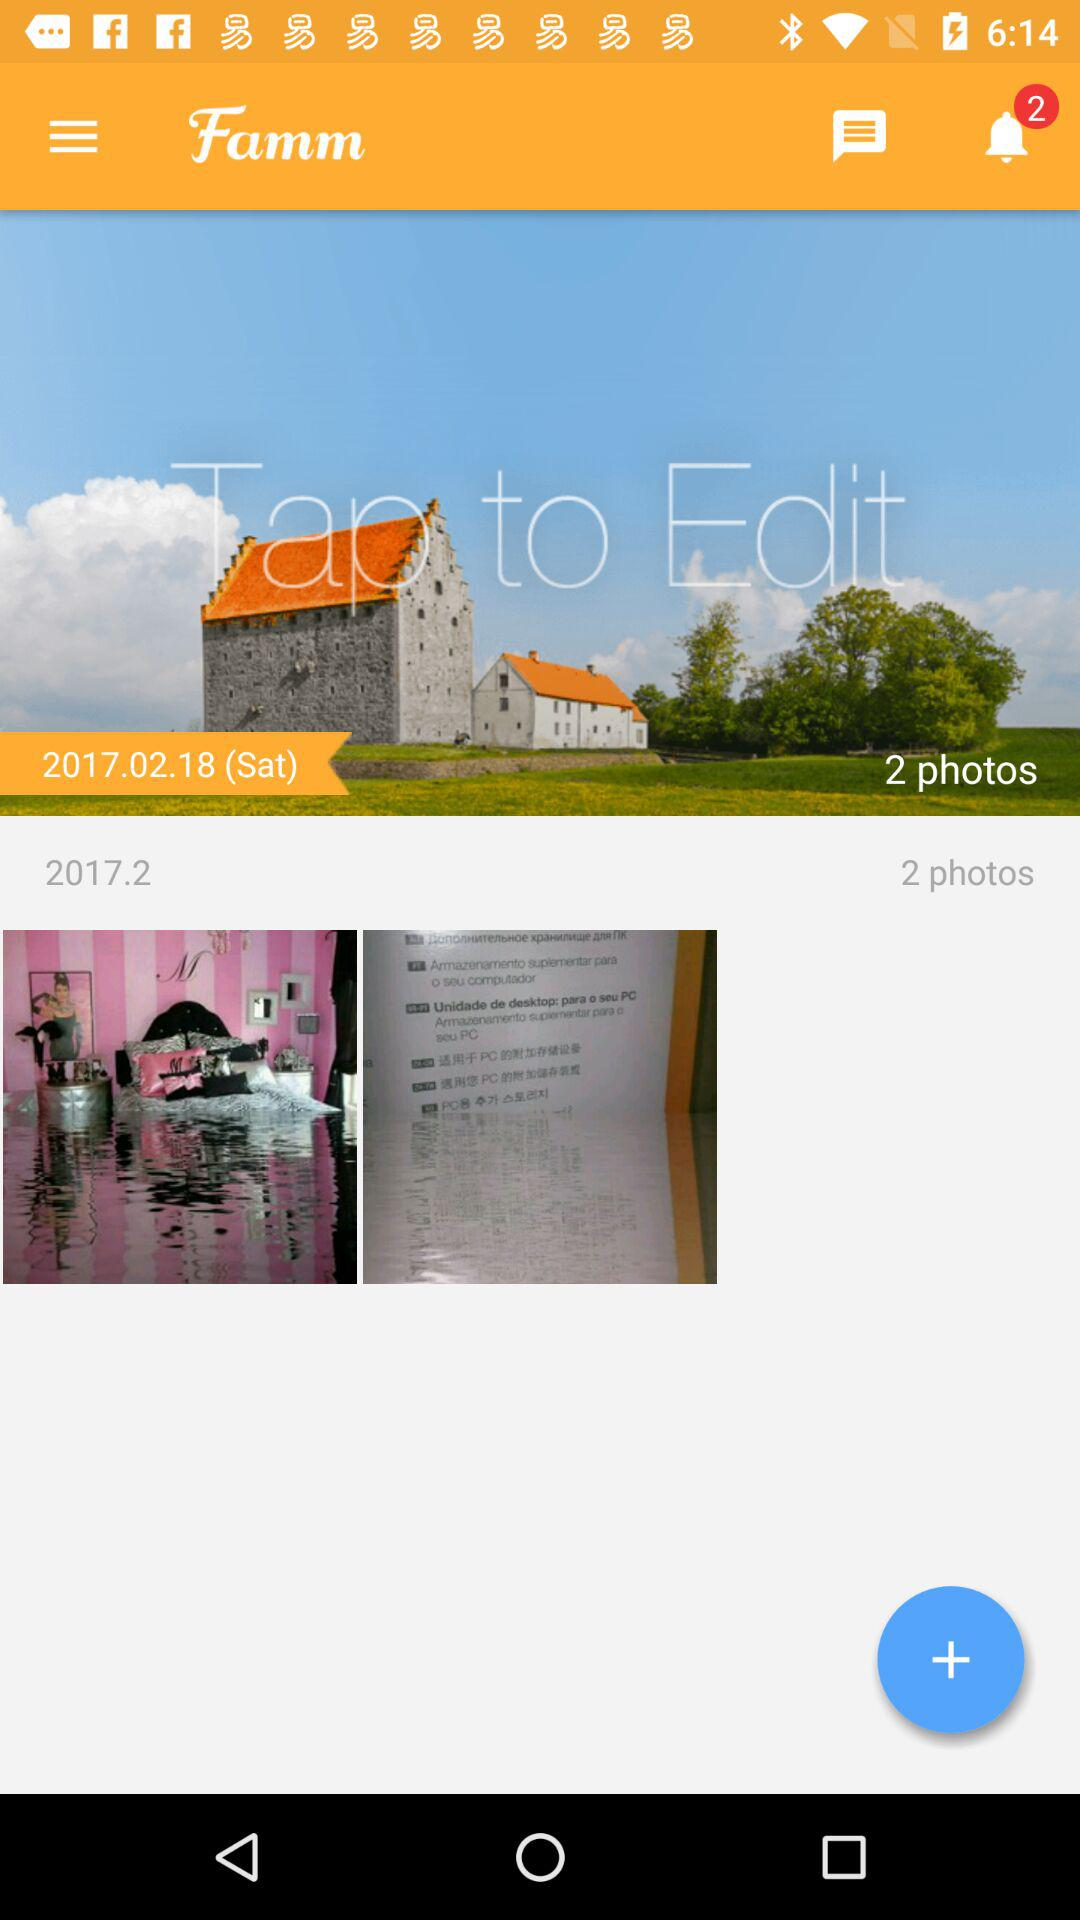How many pending notifications are there? There are 2 pending notifications. 